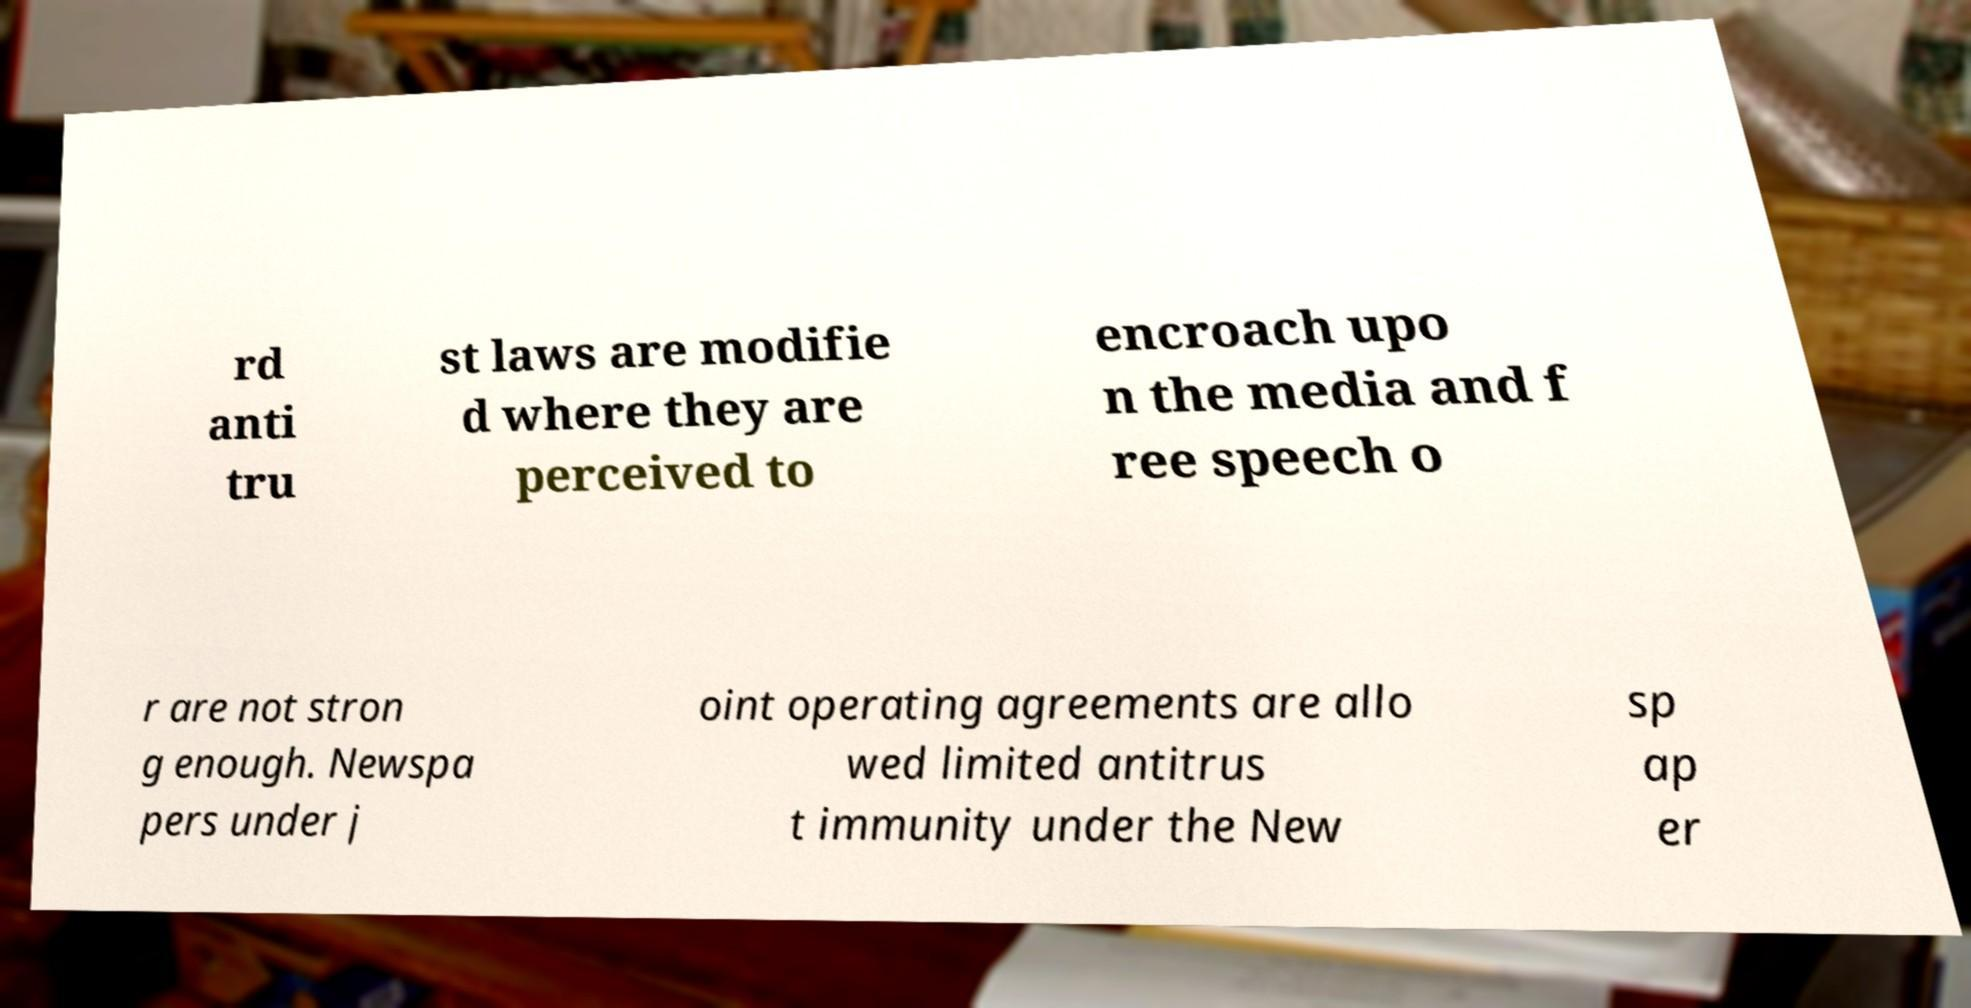Please identify and transcribe the text found in this image. rd anti tru st laws are modifie d where they are perceived to encroach upo n the media and f ree speech o r are not stron g enough. Newspa pers under j oint operating agreements are allo wed limited antitrus t immunity under the New sp ap er 